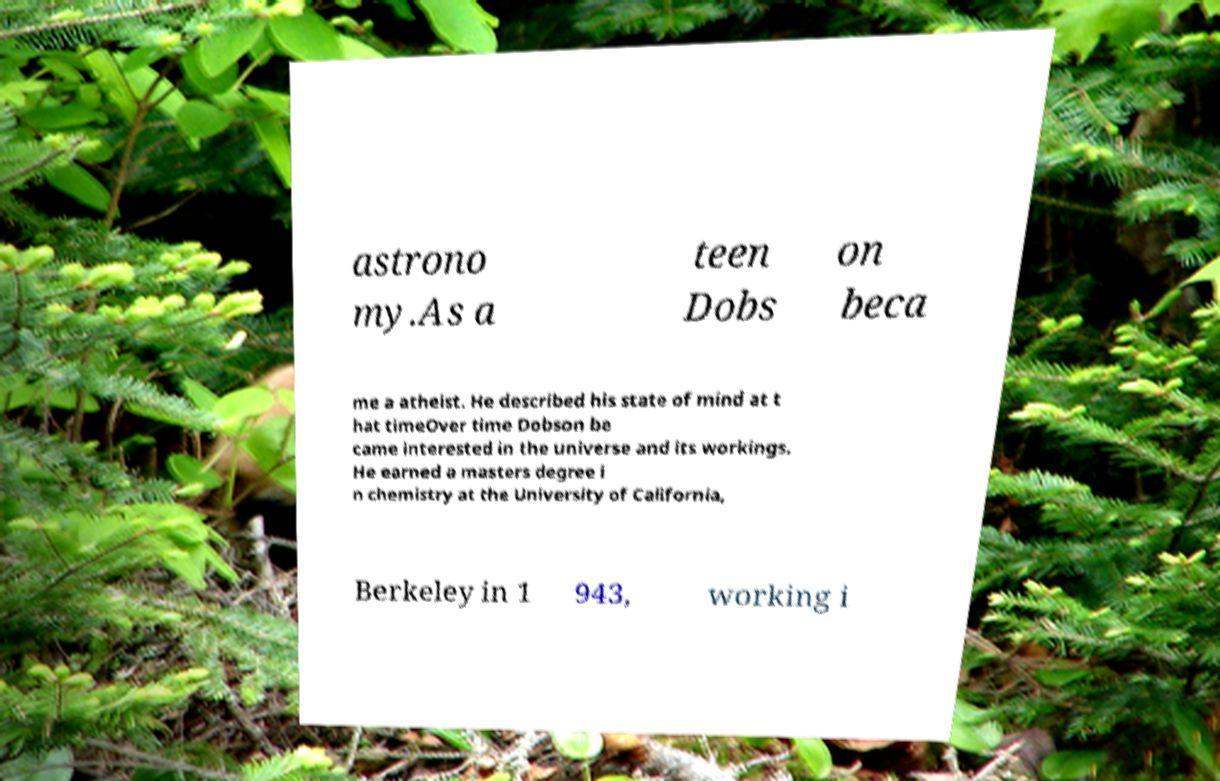I need the written content from this picture converted into text. Can you do that? astrono my.As a teen Dobs on beca me a atheist. He described his state of mind at t hat timeOver time Dobson be came interested in the universe and its workings. He earned a masters degree i n chemistry at the University of California, Berkeley in 1 943, working i 